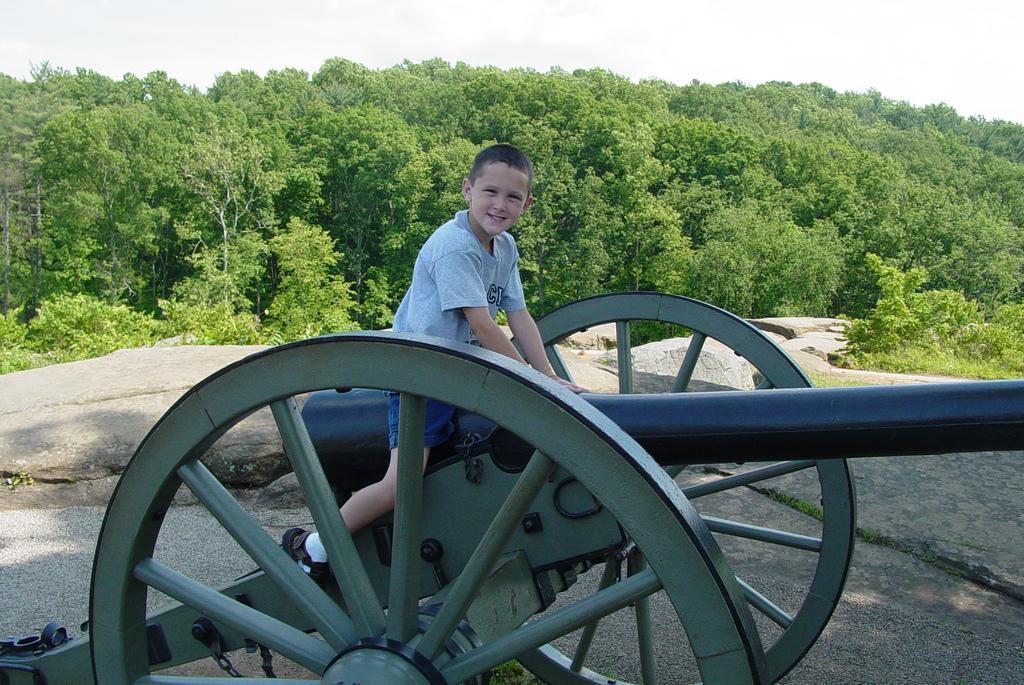In one or two sentences, can you explain what this image depicts? This boy is highlighted in this picture. Far there are number of trees in green color. Sky is in white color. This boy sat on a military weapon. Wheels. 